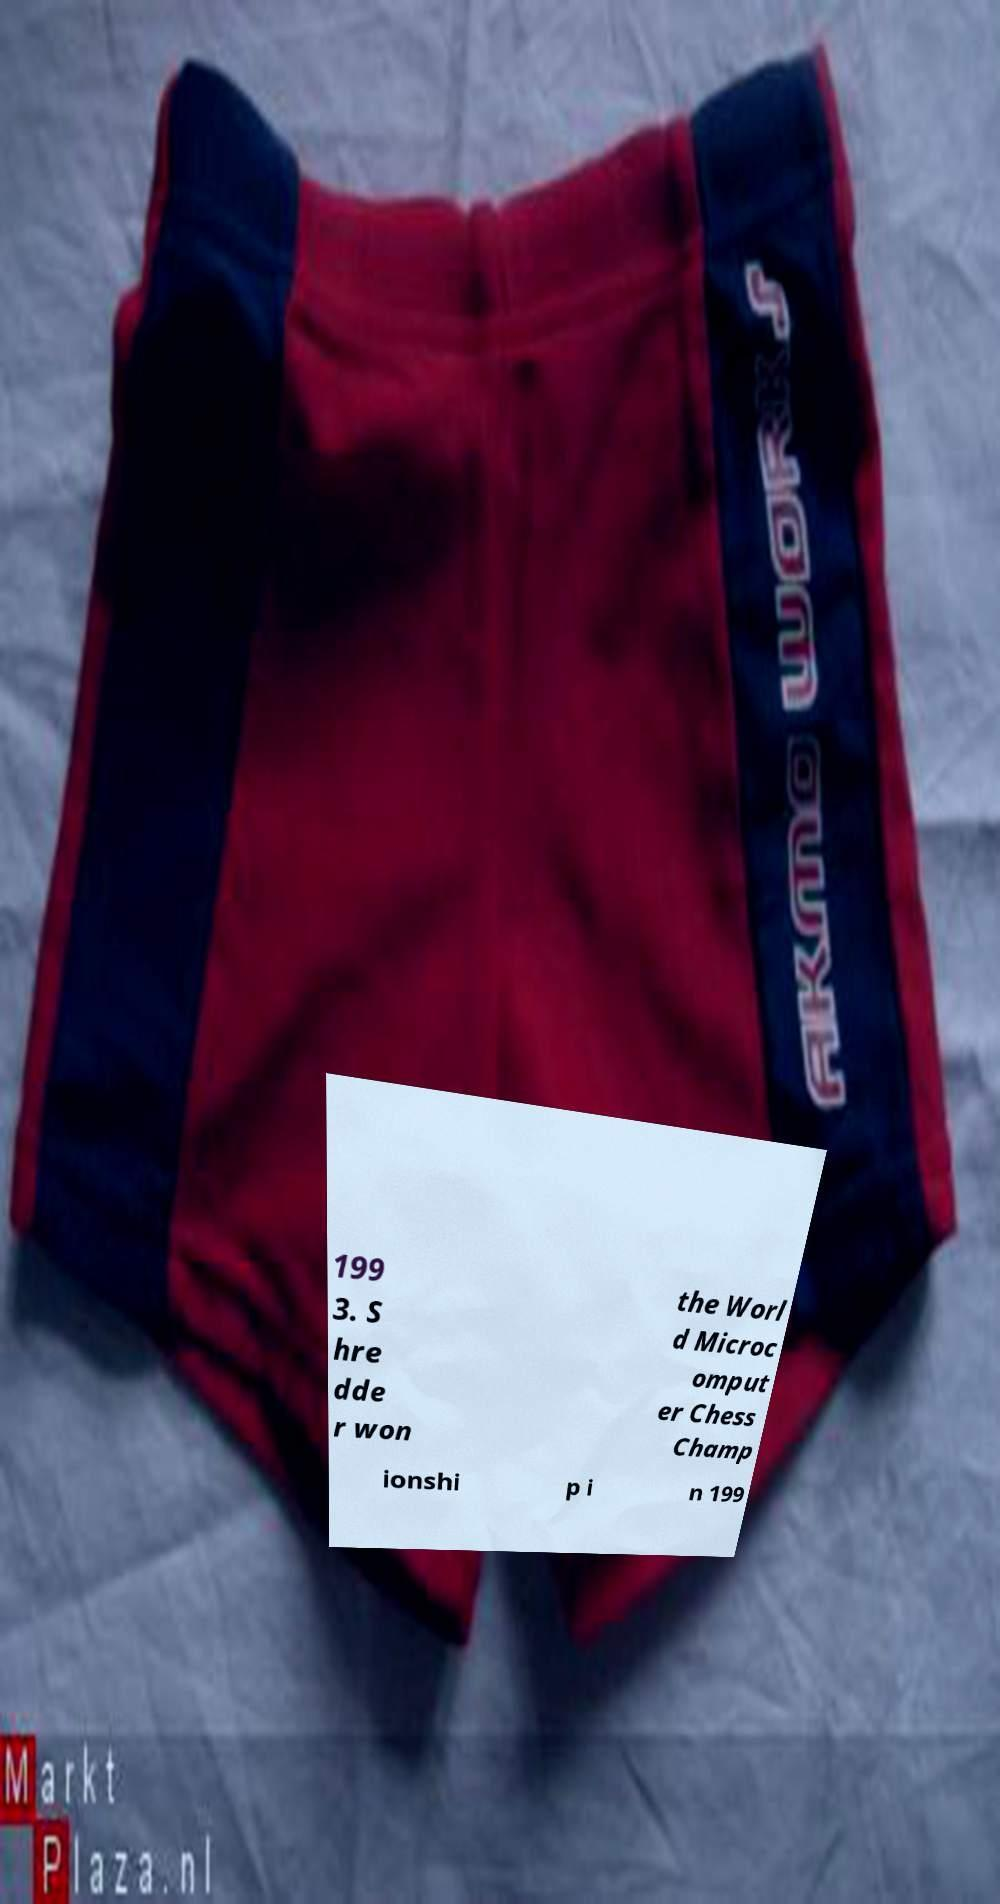Please identify and transcribe the text found in this image. 199 3. S hre dde r won the Worl d Microc omput er Chess Champ ionshi p i n 199 